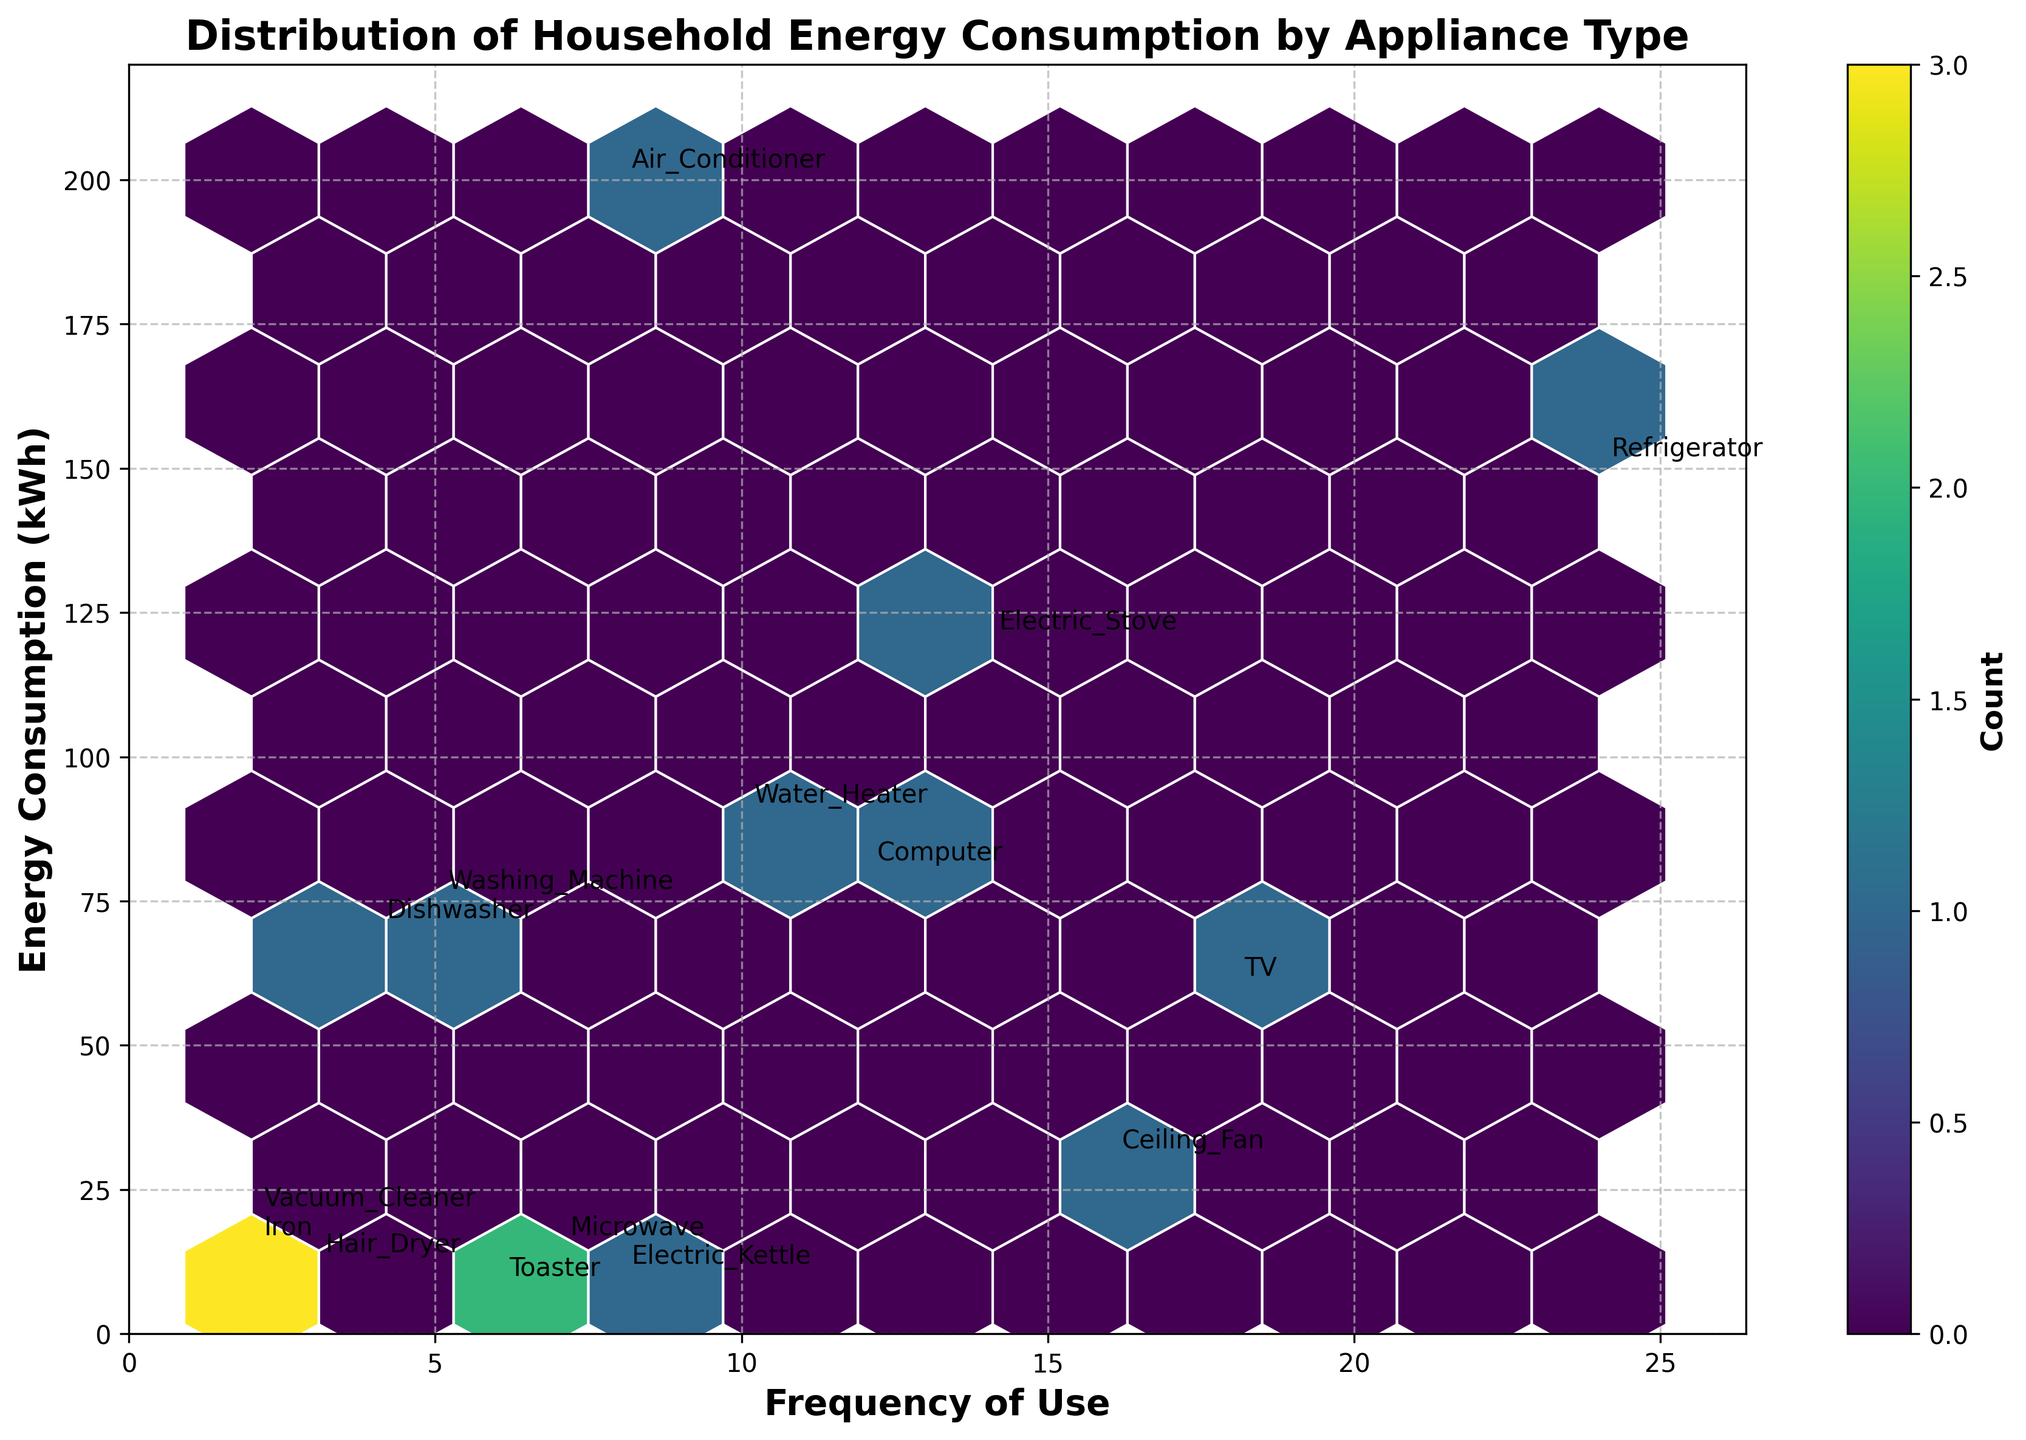What is the title of the figure? The title of the figure is usually displayed at the top of the plot, here it states "Distribution of Household Energy Consumption by Appliance Type".
Answer: Distribution of Household Energy Consumption by Appliance Type What does the x-axis represent? The label on the x-axis indicates that it represents the frequency of use of the appliances.
Answer: Frequency of Use What does the y-axis represent? The label on the y-axis shows that it represents the energy consumption measured in kilowatt-hours (kWh).
Answer: Energy Consumption (kWh) Which appliance has the highest energy consumption? Checking the y-axis position of each annotated appliance, the highest value corresponds to "Air Conditioner" at 200 kWh.
Answer: Air Conditioner Which appliance is used the most frequently? By examining the x-axis position, the "Refrigerator" appears at the highest value of 24 uses.
Answer: Refrigerator Which appliance has the lowest energy consumption? Observing the y-axis for the smallest value, "Toaster" has the lowest energy consumption at 8 kWh.
Answer: Toaster How does the frequency of use impact the distribution of energy consumption? Observing the distribution of hexagons, a pattern or concentration of counts may reveal whether higher frequency appliances tend to have specific energy consumption ranges, showing clusters.
Answer: Clusters are formed around moderate energy use with varied frequencies Which appliances consume less than 50 kWh? Checking the y-axis for values below 50 kWh and finding the corresponding appliances, they are "Microwave", "Vacuum Cleaner", "Ceiling Fan", "Toaster", "Electric Kettle", "Hair Dryer", and "Iron".
Answer: Microwave, Vacuum Cleaner, Ceiling Fan, Toaster, Electric Kettle, Hair Dryer, Iron How many appliances consume between 50 kWh and 100 kWh? By identifying appliances on the y-axis between 50 kWh and 100 kWh, they are "TV", "Computer", and "Water Heater".
Answer: Three appliances What is the frequency of use for the washing machine? Refer to the x-axis annotation for "Washing Machine", which indicates a frequency of 5.
Answer: 5 Compare the energy consumption of the "Electric Stove" and "Washing Machine". Which one uses more energy, and by how much? The y-axis positions show "Electric Stove" uses 120 kWh and "Washing Machine" uses 75 kWh. The difference is 120 - 75 = 45 kWh.
Answer: Electric Stove uses 45 kWh more 